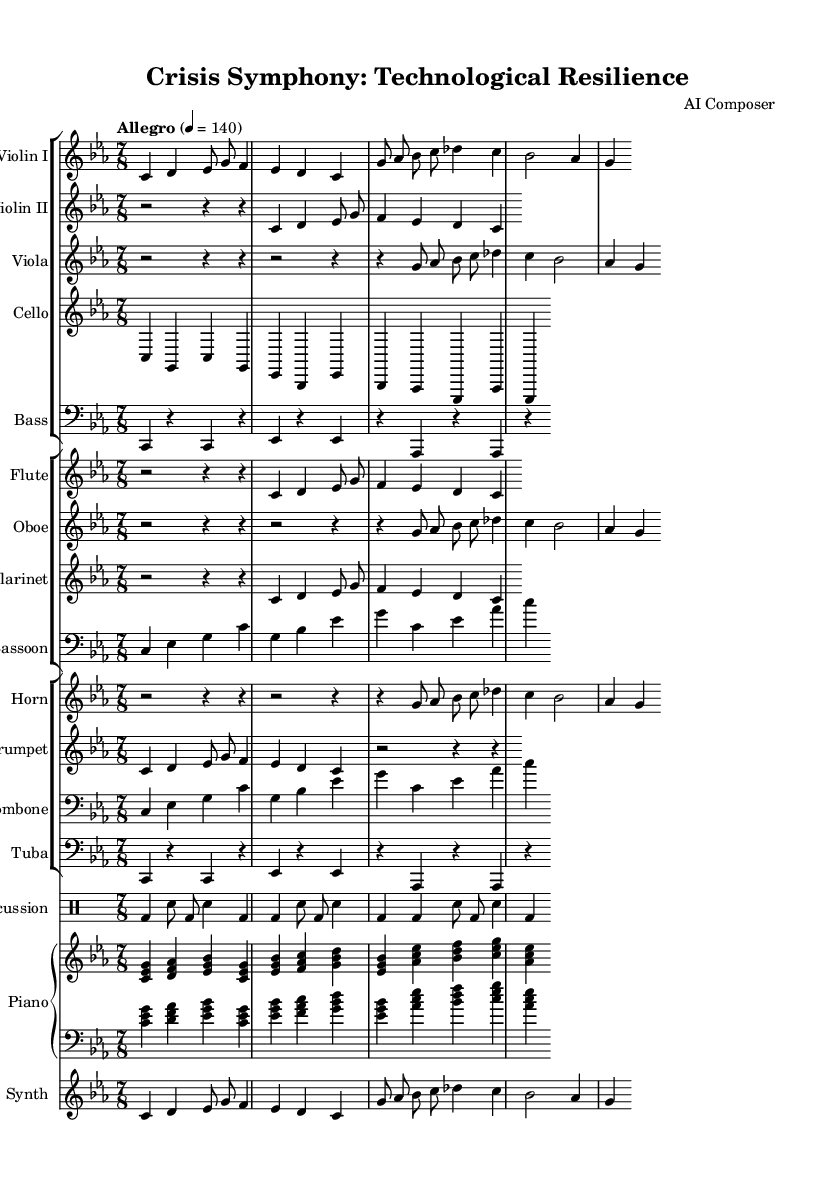What is the key signature of this music? The key signature is indicated at the beginning of the staff and shows the notes that will be sharp or flat throughout the piece. In this case, it specifies C minor, which has three flats (B-flat, E-flat, A-flat).
Answer: C minor What is the time signature of this symphony? The time signature is found at the beginning of the piece, next to the key signature. Here, it is indicated as 7/8, meaning there are seven beats per measure, and the eighth note gets one beat.
Answer: 7/8 What is the tempo marking of the symphony? The tempo can be identified in the score where it states "Allegro" followed by a metronome marking of 140, which indicates the pace at which the piece should be performed.
Answer: Allegro 4 = 140 How many instruments are featured in this symphony? The number of instruments can be determined by counting the distinct staves in the score. There are multiple staff groups including strings, woodwinds, brass, percussion, piano, and synth, amounting to a total of 18 individual parts.
Answer: 18 Which melodic motif represents a crisis? To identify motifs representing crisis, we look at the defined musical phrases in the score. The crisis motif, described as "c4 d4 es8 g8 f4 es4 d4 c4" in the violin part, serves to depict moments of tension or unease.
Answer: crisisMotif What instruments play the technology theme? The technology theme is played by the instruments denoted in the score sections where the phrase appears, specifically in Violin I, Viola, Oboe, Horn, and Synth.
Answer: Violin I, Viola, Oboe, Horn, Synth What role does percussion play in this symphony? The score shows that percussion provides a rhythmic backbone; its part includes bass drums and snare hits to enhance the dramatic elements of crisis and technology, serving as a contrast to the melodic lines.
Answer: Rhythmic backbone 